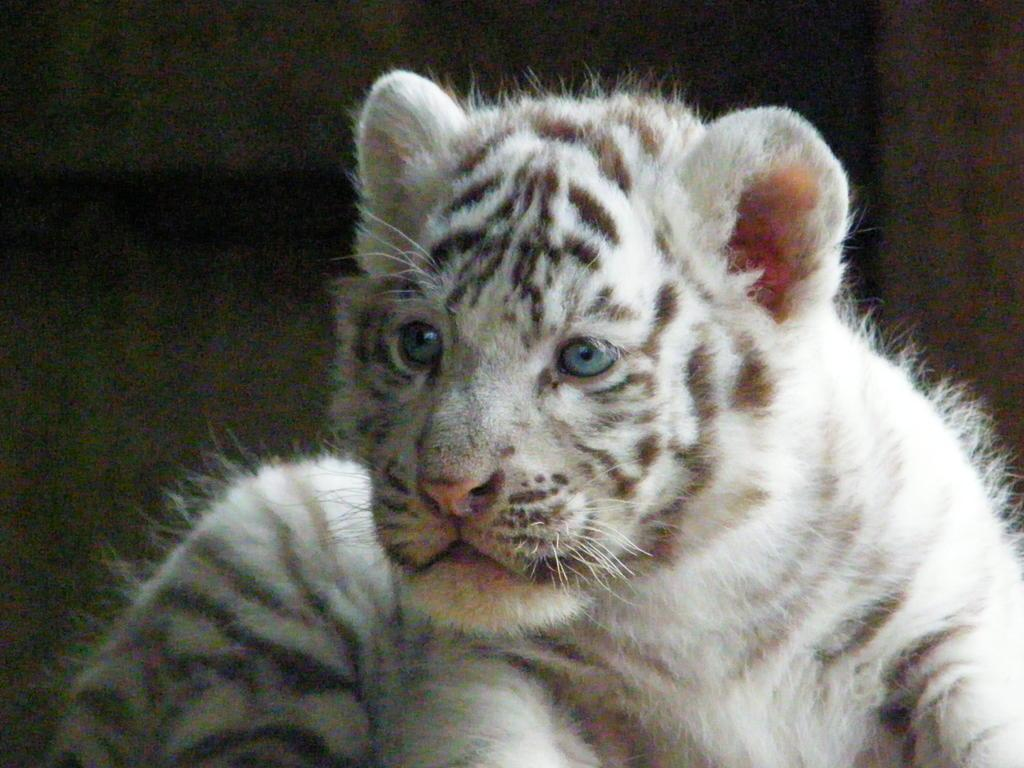What animal is present in the image? There is a tiger in the image. What can be seen in the background of the image? There is a wall in the background of the image. What type of sofa can be seen in the image? There is no sofa present in the image; it features a tiger and a wall in the background. What arithmetic problem is the tiger solving in the image? There is no arithmetic problem present in the image; it features a tiger and a wall in the background. 